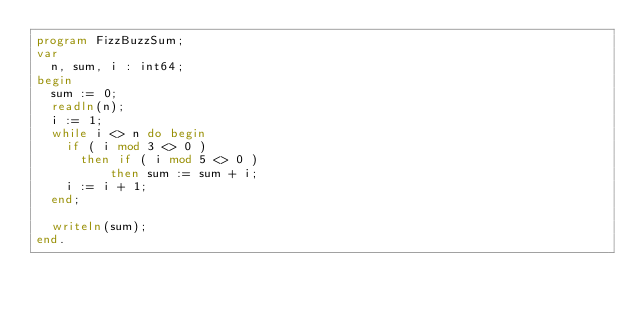<code> <loc_0><loc_0><loc_500><loc_500><_Pascal_>program FizzBuzzSum;
var
	n, sum, i : int64; 
begin	
	sum := 0;
	readln(n);
	i := 1;
	while i <> n do begin
		if ( i mod 3 <> 0 )
			then if ( i mod 5 <> 0 )
					then sum := sum + i;
		i := i + 1;
	end;
		
	writeln(sum);
end.</code> 